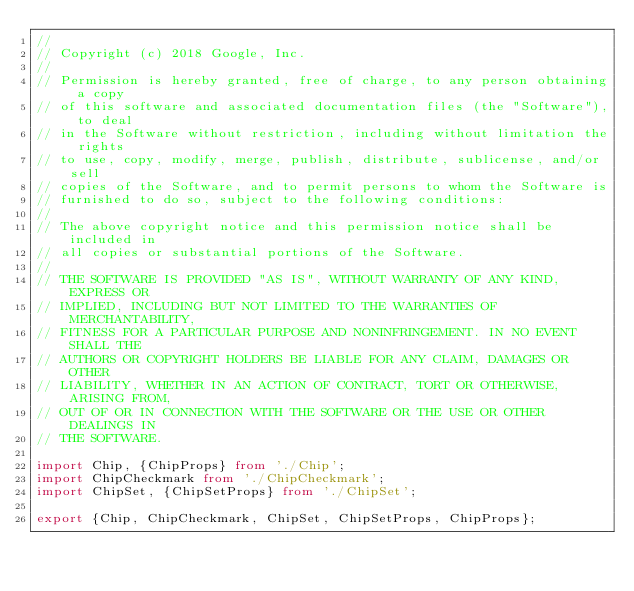<code> <loc_0><loc_0><loc_500><loc_500><_TypeScript_>//
// Copyright (c) 2018 Google, Inc.
//
// Permission is hereby granted, free of charge, to any person obtaining a copy
// of this software and associated documentation files (the "Software"), to deal
// in the Software without restriction, including without limitation the rights
// to use, copy, modify, merge, publish, distribute, sublicense, and/or sell
// copies of the Software, and to permit persons to whom the Software is
// furnished to do so, subject to the following conditions:
//
// The above copyright notice and this permission notice shall be included in
// all copies or substantial portions of the Software.
//
// THE SOFTWARE IS PROVIDED "AS IS", WITHOUT WARRANTY OF ANY KIND, EXPRESS OR
// IMPLIED, INCLUDING BUT NOT LIMITED TO THE WARRANTIES OF MERCHANTABILITY,
// FITNESS FOR A PARTICULAR PURPOSE AND NONINFRINGEMENT. IN NO EVENT SHALL THE
// AUTHORS OR COPYRIGHT HOLDERS BE LIABLE FOR ANY CLAIM, DAMAGES OR OTHER
// LIABILITY, WHETHER IN AN ACTION OF CONTRACT, TORT OR OTHERWISE, ARISING FROM,
// OUT OF OR IN CONNECTION WITH THE SOFTWARE OR THE USE OR OTHER DEALINGS IN
// THE SOFTWARE.

import Chip, {ChipProps} from './Chip';
import ChipCheckmark from './ChipCheckmark';
import ChipSet, {ChipSetProps} from './ChipSet';

export {Chip, ChipCheckmark, ChipSet, ChipSetProps, ChipProps};
</code> 